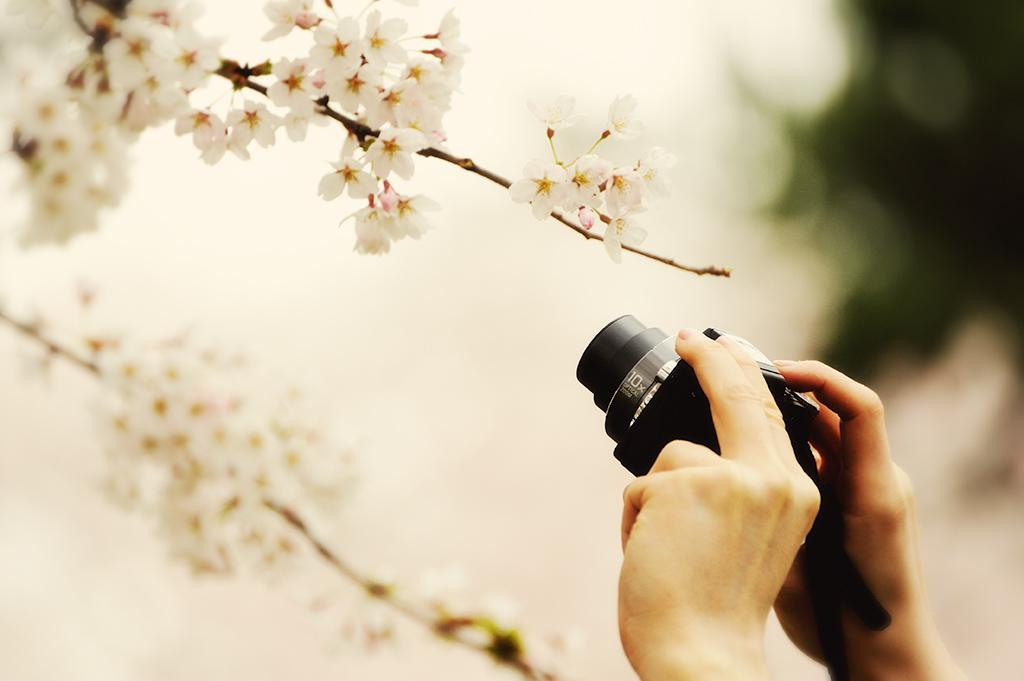What type of objects can be seen in the image? There are flowers in the image. Where is the person's hands located in the image? The person's hands holding a camera can be seen on the right side of the image. What route does the maid take to clean the flowers in the image? There is no maid present in the image, and therefore no route for cleaning the flowers can be determined. 